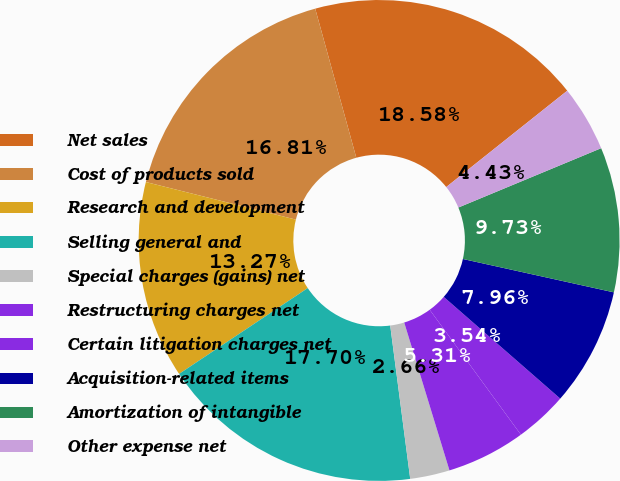<chart> <loc_0><loc_0><loc_500><loc_500><pie_chart><fcel>Net sales<fcel>Cost of products sold<fcel>Research and development<fcel>Selling general and<fcel>Special charges (gains) net<fcel>Restructuring charges net<fcel>Certain litigation charges net<fcel>Acquisition-related items<fcel>Amortization of intangible<fcel>Other expense net<nl><fcel>18.58%<fcel>16.81%<fcel>13.27%<fcel>17.7%<fcel>2.66%<fcel>5.31%<fcel>3.54%<fcel>7.96%<fcel>9.73%<fcel>4.43%<nl></chart> 